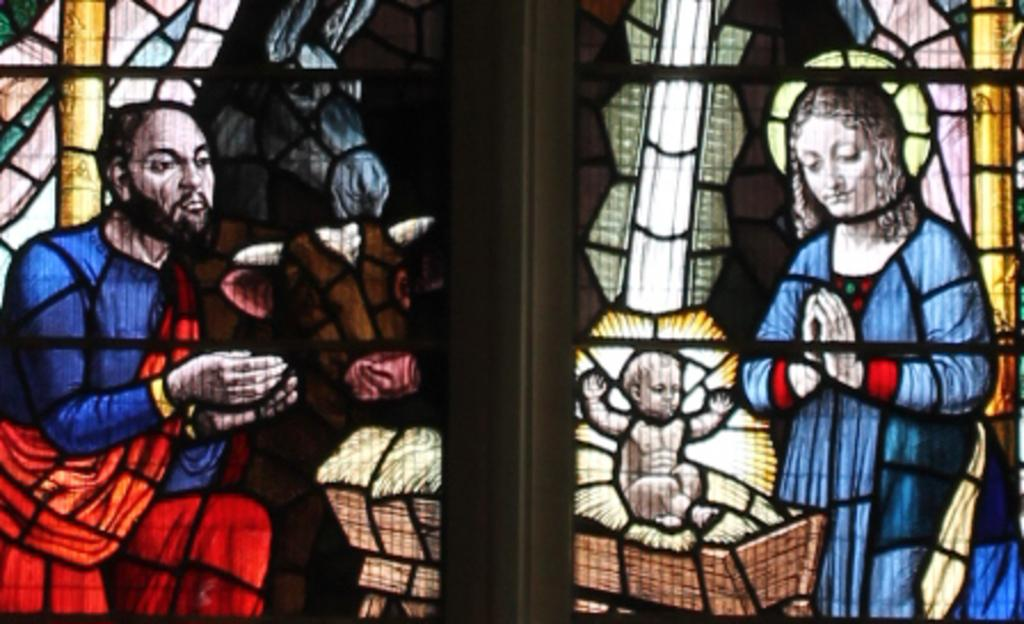How many people are present in the image? There are two people, a man and a woman, present in the image. Can you describe the third subject in the image? There is a baby in the image. What other living beings are present in the image? There are two animals in the image. What type of horn is present in the image? There is no horn present in the image. 